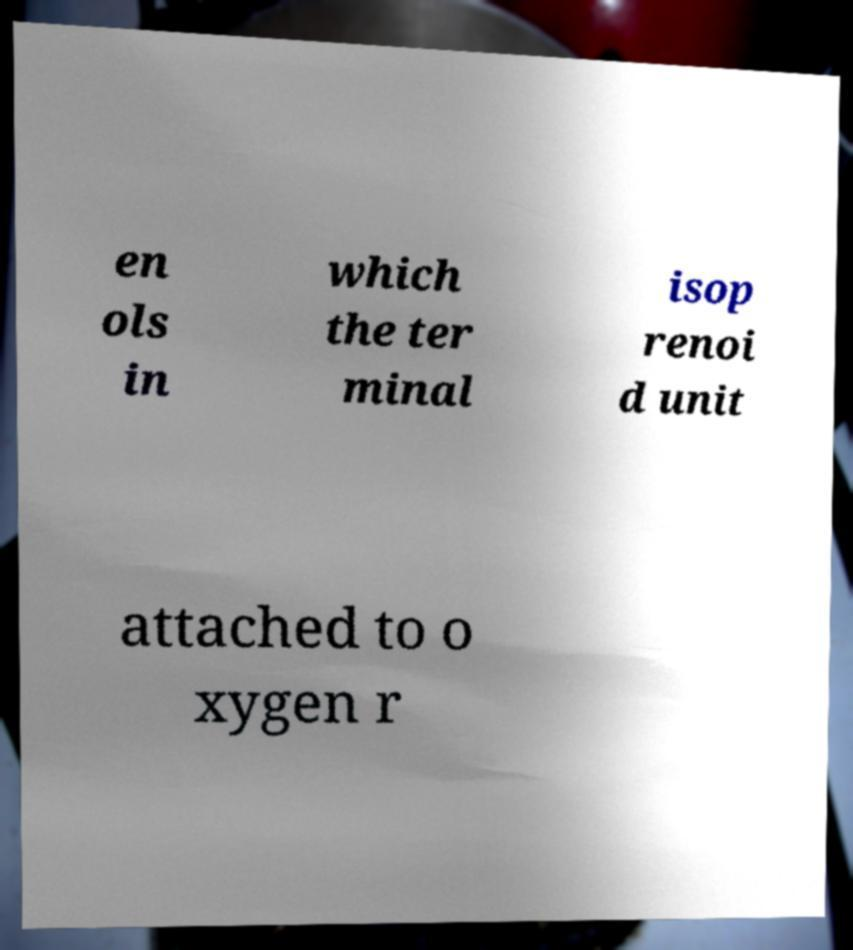Could you extract and type out the text from this image? en ols in which the ter minal isop renoi d unit attached to o xygen r 